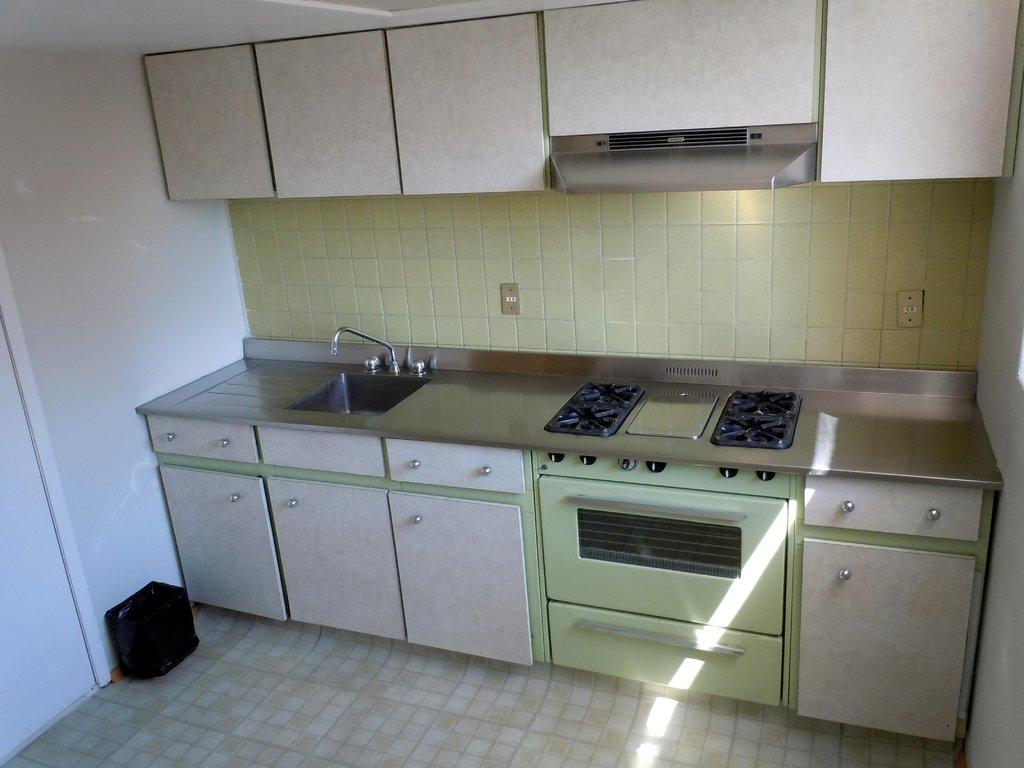What type of room is depicted in the image? The image appears to depict a kitchen. Where is the sink located in the image? The sink is on the left side of the image. What feature is associated with the sink? There is a tap associated with the sink. What cooking appliance can be seen in the middle of the image? There is a stove in the middle of the image. Can you see a receipt on the stove in the image? There is no receipt present on the stove in the image. How many bells are hanging above the sink in the image? There are no bells visible in the image; it only shows a sink and a stove in a kitchen setting. 